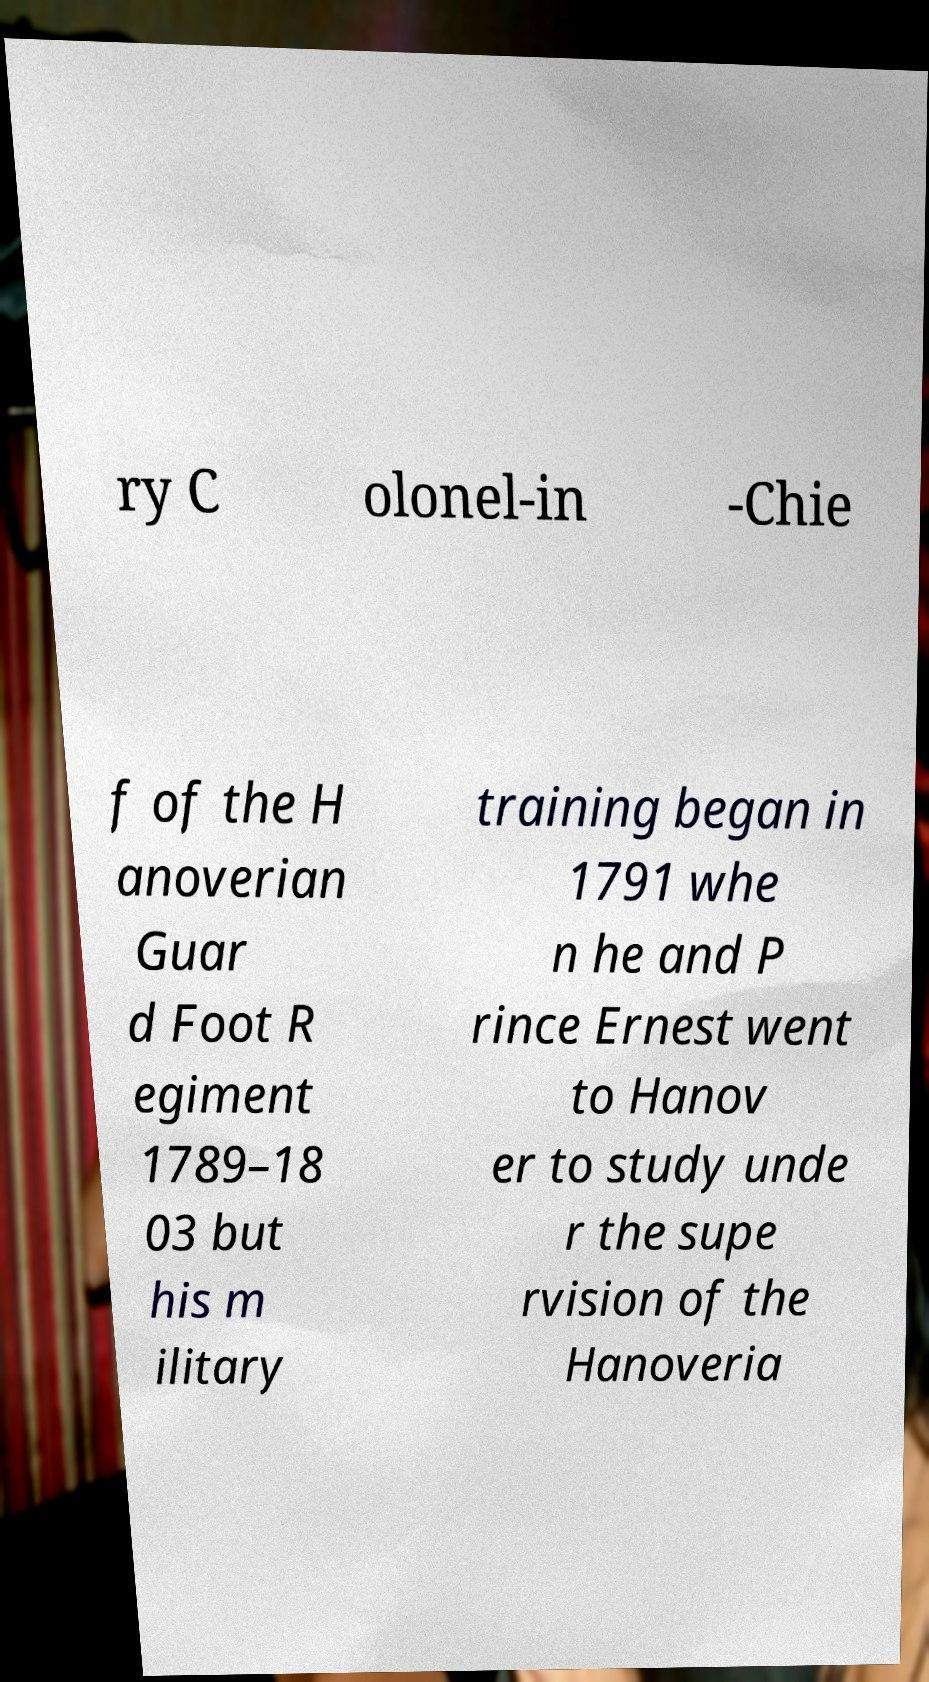For documentation purposes, I need the text within this image transcribed. Could you provide that? ry C olonel-in -Chie f of the H anoverian Guar d Foot R egiment 1789–18 03 but his m ilitary training began in 1791 whe n he and P rince Ernest went to Hanov er to study unde r the supe rvision of the Hanoveria 